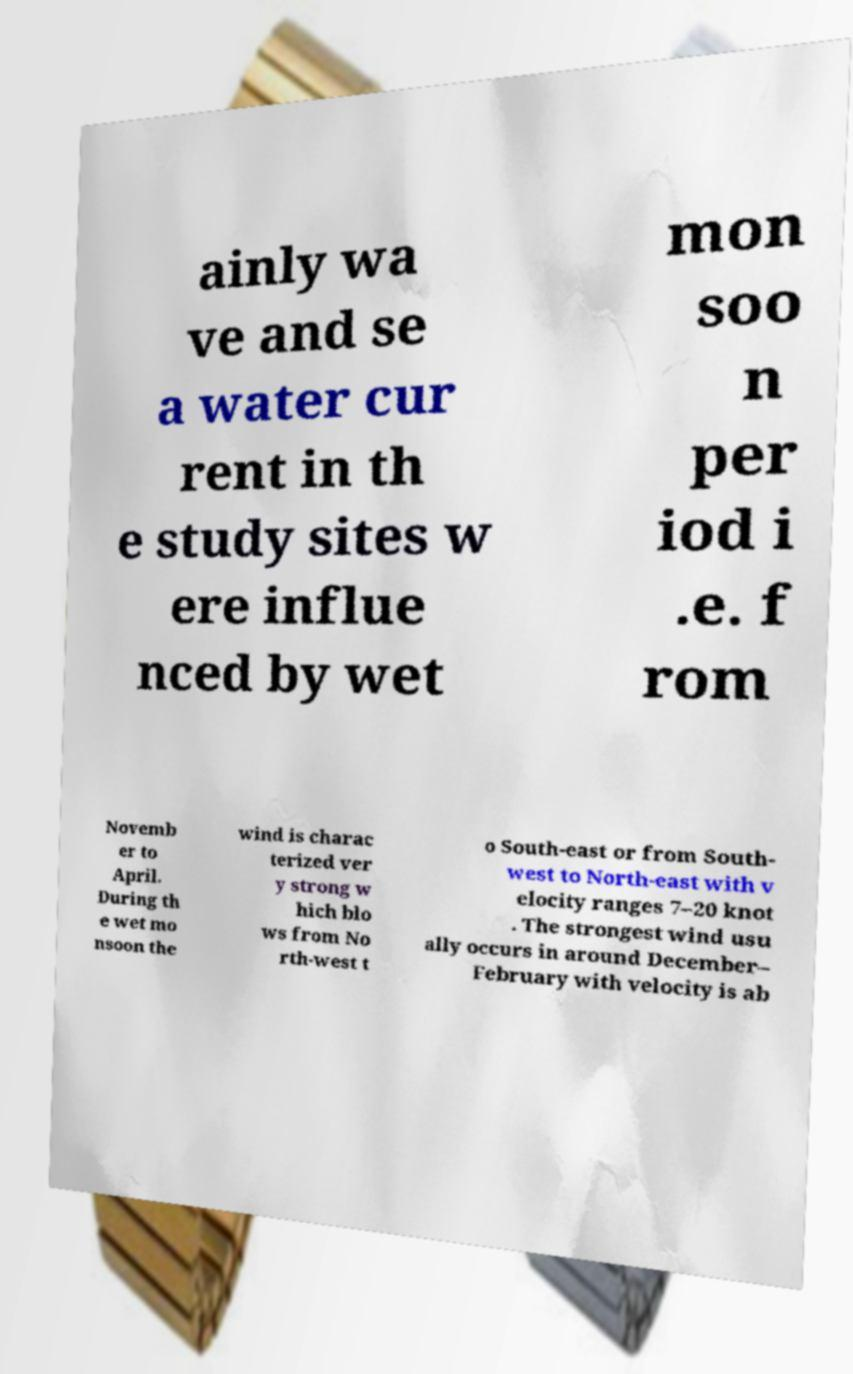Can you read and provide the text displayed in the image?This photo seems to have some interesting text. Can you extract and type it out for me? ainly wa ve and se a water cur rent in th e study sites w ere influe nced by wet mon soo n per iod i .e. f rom Novemb er to April. During th e wet mo nsoon the wind is charac terized ver y strong w hich blo ws from No rth-west t o South-east or from South- west to North-east with v elocity ranges 7–20 knot . The strongest wind usu ally occurs in around December– February with velocity is ab 